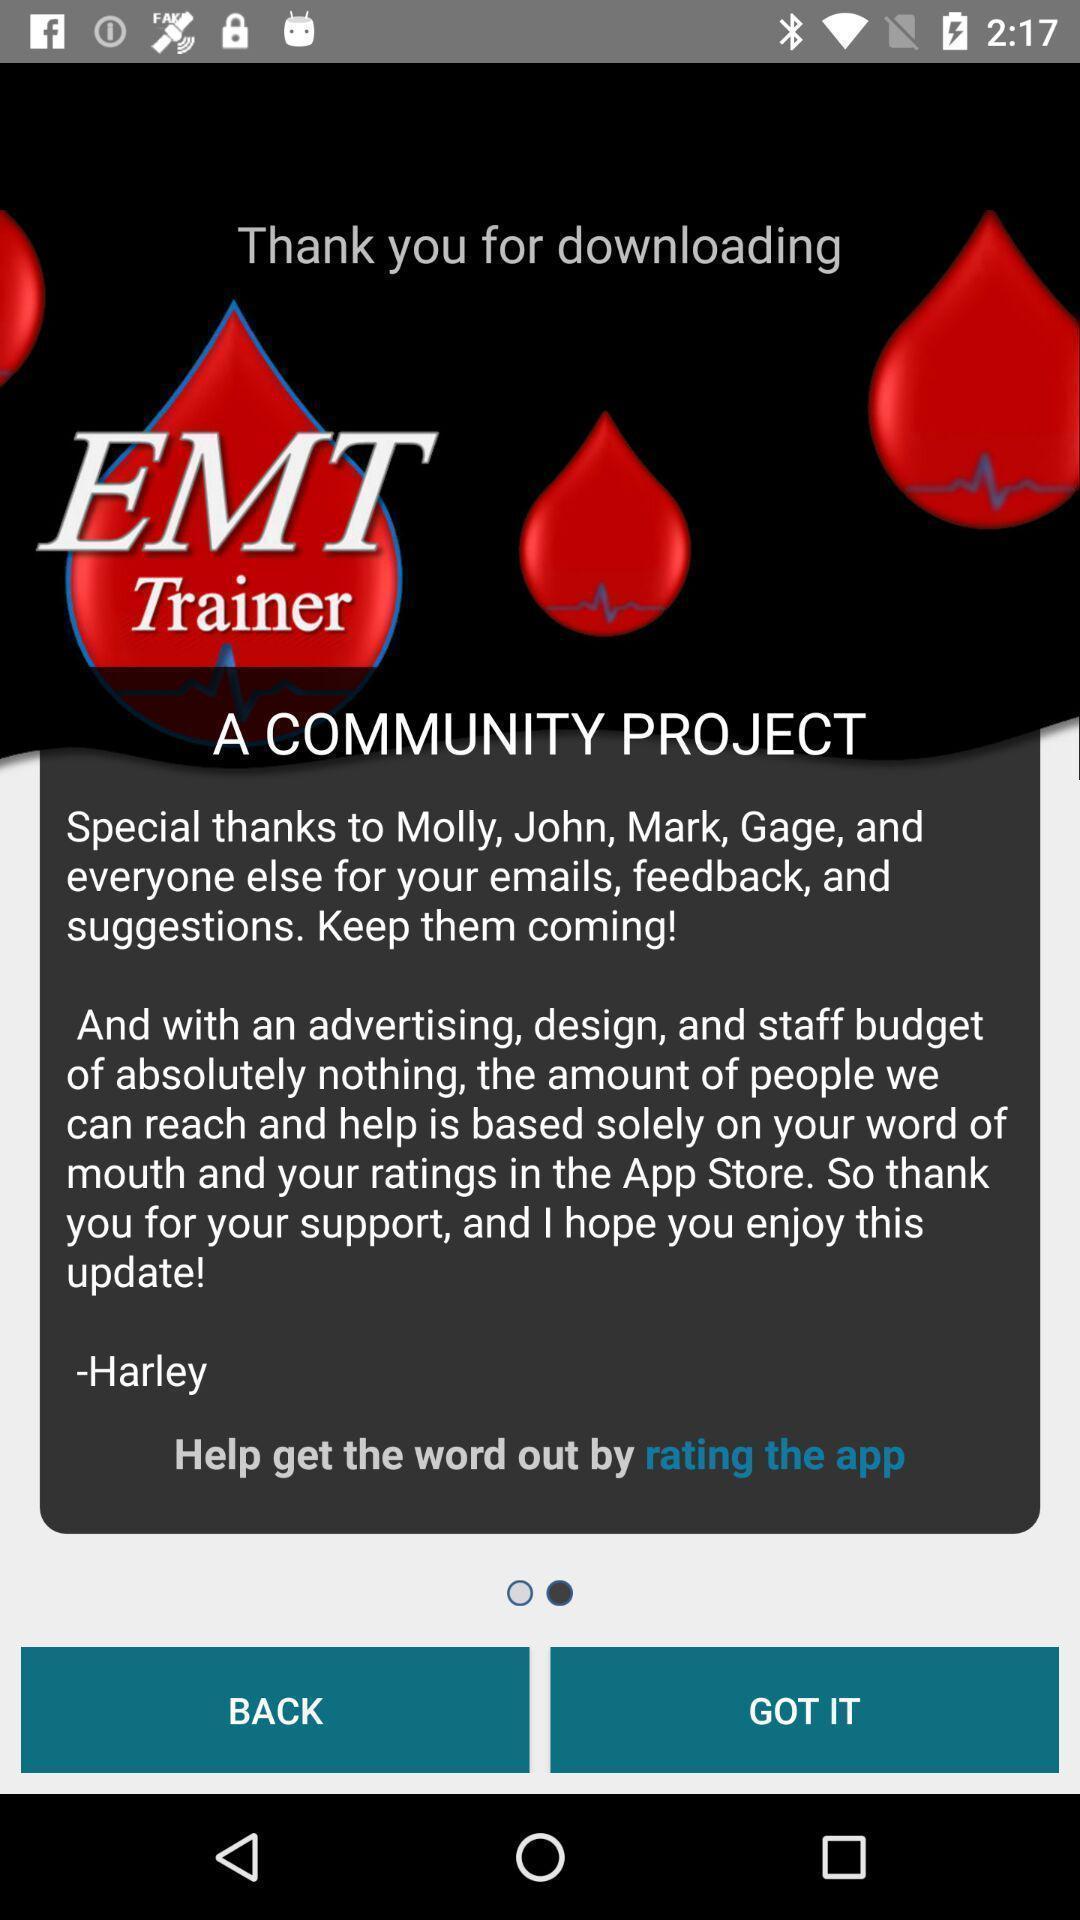What can you discern from this picture? Screen displaying the page of a medical app. 